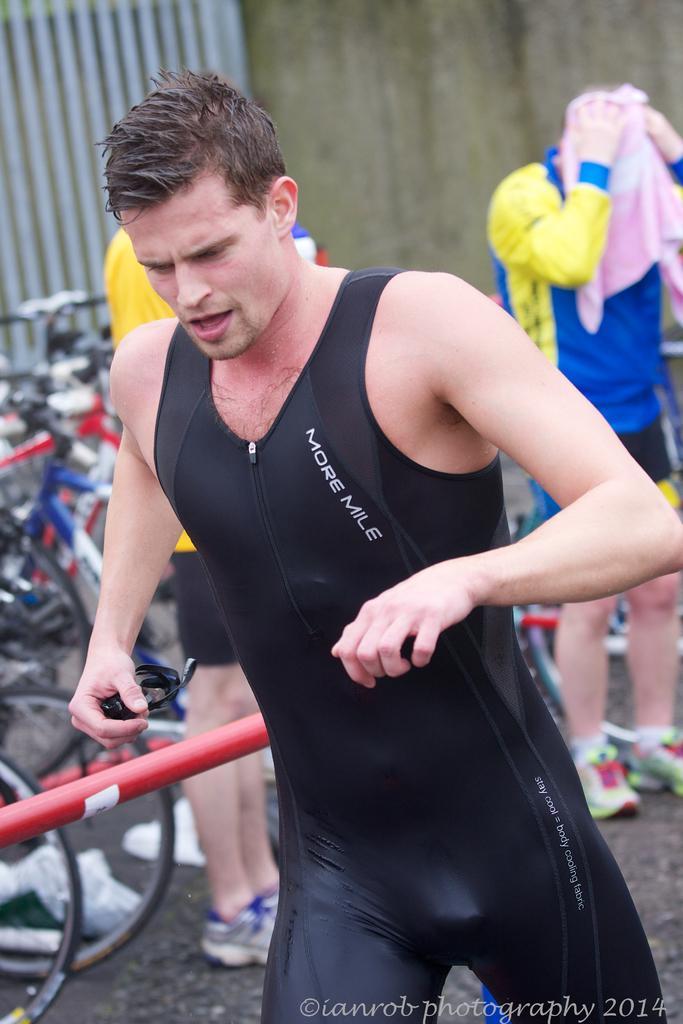How would you summarize this image in a sentence or two? This picture shows a man running and two people standing at the back and one person is rubbing his head with a towel and we can see bicycles parked. 